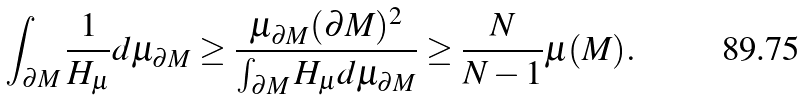Convert formula to latex. <formula><loc_0><loc_0><loc_500><loc_500>\int _ { \partial M } \frac { 1 } { H _ { \mu } } d \mu _ { \partial M } \geq \frac { \mu _ { \partial M } ( \partial M ) ^ { 2 } } { \int _ { \partial M } H _ { \mu } d \mu _ { \partial M } } \geq \frac { N } { N - 1 } \mu ( M ) .</formula> 